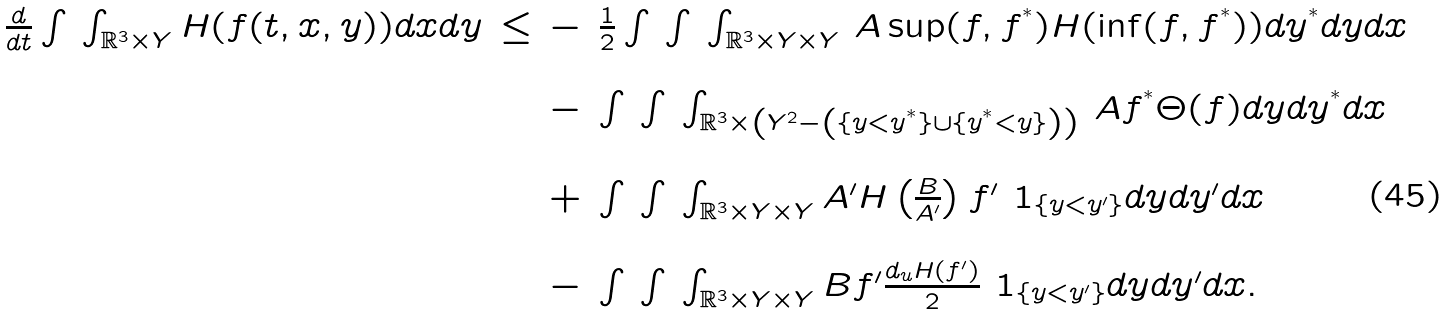<formula> <loc_0><loc_0><loc_500><loc_500>\begin{array} { l l l l } \frac { d } { d t } \int \, \int _ { \mathbb { R } ^ { 3 } \times Y } H ( f ( t , x , y ) ) d x d y & \leq & - & \frac { 1 } { 2 } \int \, \int \, \int _ { \mathbb { R } ^ { 3 } \times Y \times Y } \, A \sup ( f , f ^ { ^ { * } } ) H ( \inf ( f , f ^ { ^ { * } } ) ) d y ^ { ^ { * } } d y d x \\ \\ & & - & \int \, \int \, \int _ { \mathbb { R } ^ { 3 } \times \left ( Y ^ { 2 } - \left ( \{ y < y ^ { ^ { * } } \} \cup \{ y ^ { ^ { * } } < y \} \right ) \right ) } \, A f ^ { ^ { * } } \Theta ( f ) d y d y ^ { ^ { * } } d x \\ \\ & & + & \int \, \int \, \int _ { \mathbb { R } ^ { 3 } \times Y \times Y } A ^ { \prime } H \left ( \frac { B } { A ^ { \prime } } \right ) f ^ { \prime } \ 1 _ { \{ y < y ^ { \prime } \} } d y d y ^ { \prime } d x \\ \\ & & - & \int \, \int \, \int _ { \mathbb { R } ^ { 3 } \times Y \times Y } B f ^ { \prime } \frac { d _ { u } H ( f ^ { \prime } ) } { 2 } \ 1 _ { \{ y < y ^ { \prime } \} } d y d y ^ { \prime } d x . \end{array}</formula> 